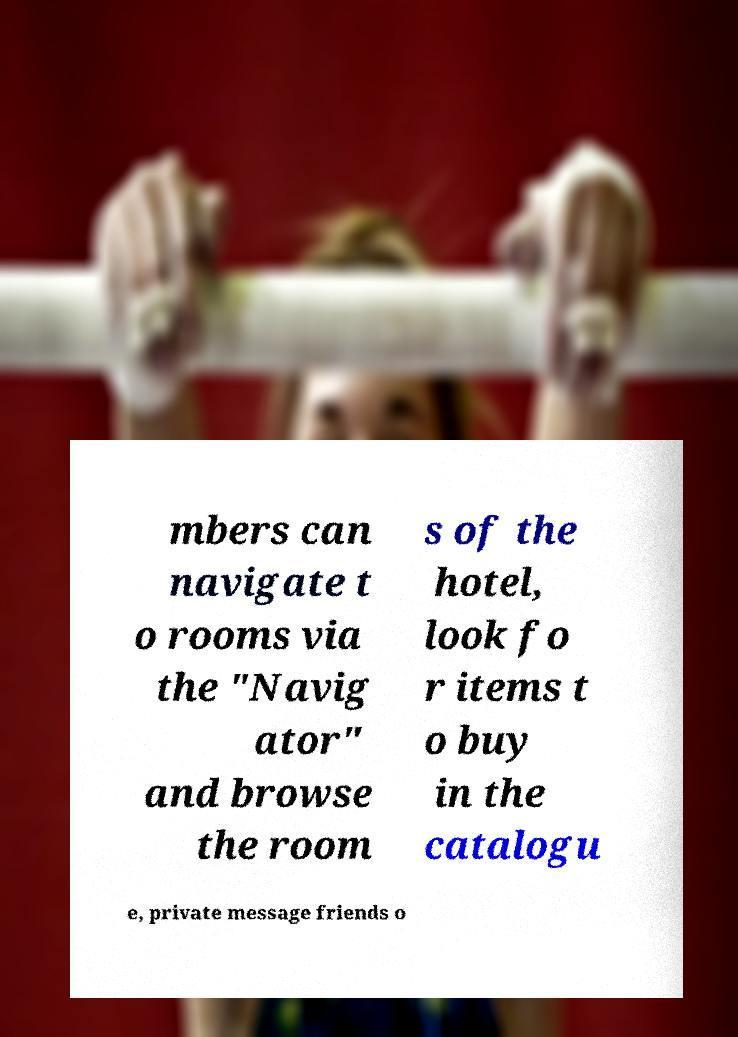Could you extract and type out the text from this image? mbers can navigate t o rooms via the "Navig ator" and browse the room s of the hotel, look fo r items t o buy in the catalogu e, private message friends o 